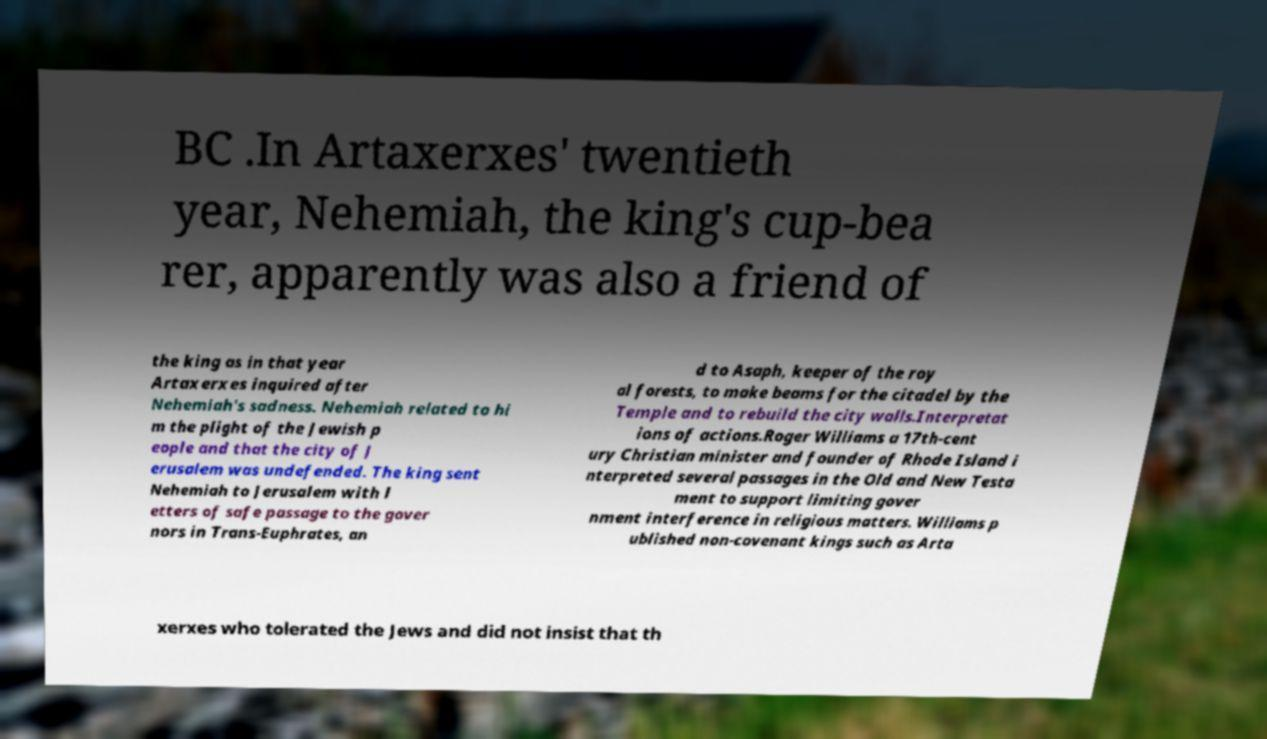Can you read and provide the text displayed in the image?This photo seems to have some interesting text. Can you extract and type it out for me? BC .In Artaxerxes' twentieth year, Nehemiah, the king's cup-bea rer, apparently was also a friend of the king as in that year Artaxerxes inquired after Nehemiah's sadness. Nehemiah related to hi m the plight of the Jewish p eople and that the city of J erusalem was undefended. The king sent Nehemiah to Jerusalem with l etters of safe passage to the gover nors in Trans-Euphrates, an d to Asaph, keeper of the roy al forests, to make beams for the citadel by the Temple and to rebuild the city walls.Interpretat ions of actions.Roger Williams a 17th-cent ury Christian minister and founder of Rhode Island i nterpreted several passages in the Old and New Testa ment to support limiting gover nment interference in religious matters. Williams p ublished non-covenant kings such as Arta xerxes who tolerated the Jews and did not insist that th 